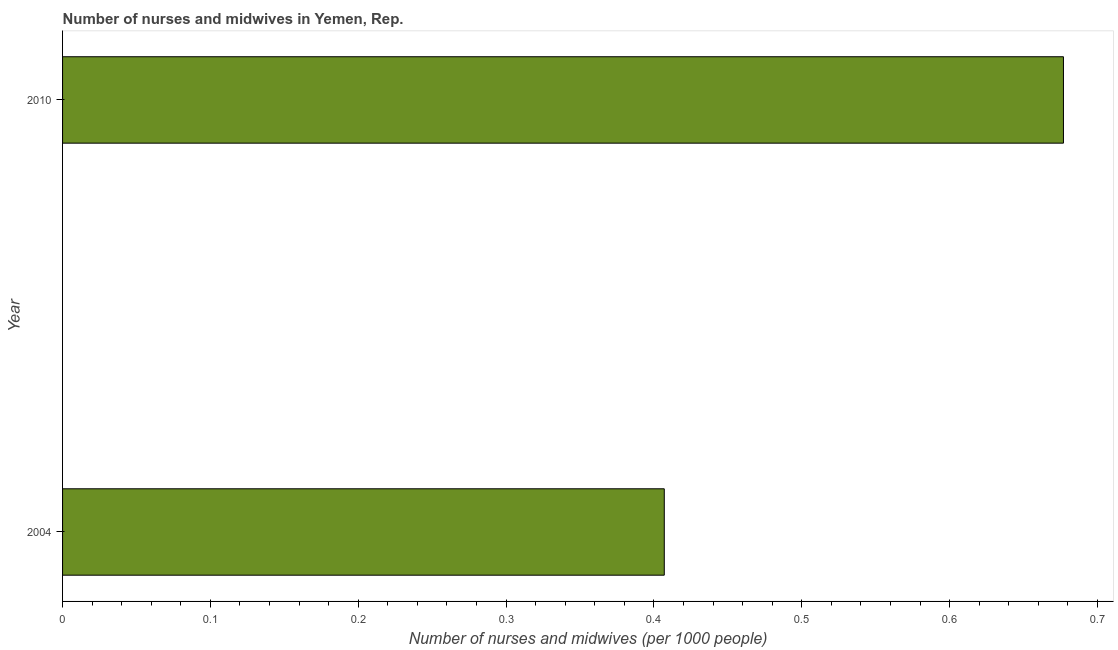Does the graph contain any zero values?
Ensure brevity in your answer.  No. Does the graph contain grids?
Give a very brief answer. No. What is the title of the graph?
Your response must be concise. Number of nurses and midwives in Yemen, Rep. What is the label or title of the X-axis?
Your response must be concise. Number of nurses and midwives (per 1000 people). What is the number of nurses and midwives in 2004?
Your answer should be compact. 0.41. Across all years, what is the maximum number of nurses and midwives?
Provide a succinct answer. 0.68. Across all years, what is the minimum number of nurses and midwives?
Offer a very short reply. 0.41. What is the sum of the number of nurses and midwives?
Your response must be concise. 1.08. What is the difference between the number of nurses and midwives in 2004 and 2010?
Make the answer very short. -0.27. What is the average number of nurses and midwives per year?
Your answer should be compact. 0.54. What is the median number of nurses and midwives?
Provide a short and direct response. 0.54. What is the ratio of the number of nurses and midwives in 2004 to that in 2010?
Your response must be concise. 0.6. What is the Number of nurses and midwives (per 1000 people) in 2004?
Your response must be concise. 0.41. What is the Number of nurses and midwives (per 1000 people) in 2010?
Give a very brief answer. 0.68. What is the difference between the Number of nurses and midwives (per 1000 people) in 2004 and 2010?
Make the answer very short. -0.27. What is the ratio of the Number of nurses and midwives (per 1000 people) in 2004 to that in 2010?
Give a very brief answer. 0.6. 